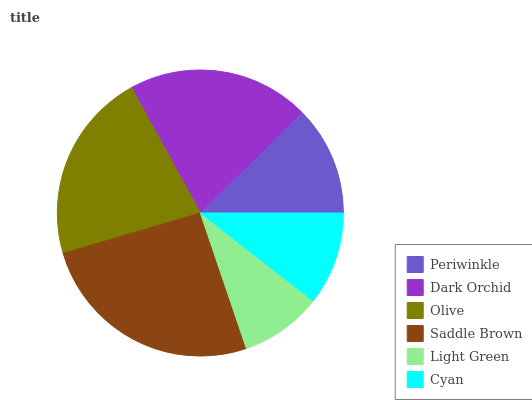Is Light Green the minimum?
Answer yes or no. Yes. Is Saddle Brown the maximum?
Answer yes or no. Yes. Is Dark Orchid the minimum?
Answer yes or no. No. Is Dark Orchid the maximum?
Answer yes or no. No. Is Dark Orchid greater than Periwinkle?
Answer yes or no. Yes. Is Periwinkle less than Dark Orchid?
Answer yes or no. Yes. Is Periwinkle greater than Dark Orchid?
Answer yes or no. No. Is Dark Orchid less than Periwinkle?
Answer yes or no. No. Is Dark Orchid the high median?
Answer yes or no. Yes. Is Periwinkle the low median?
Answer yes or no. Yes. Is Cyan the high median?
Answer yes or no. No. Is Saddle Brown the low median?
Answer yes or no. No. 